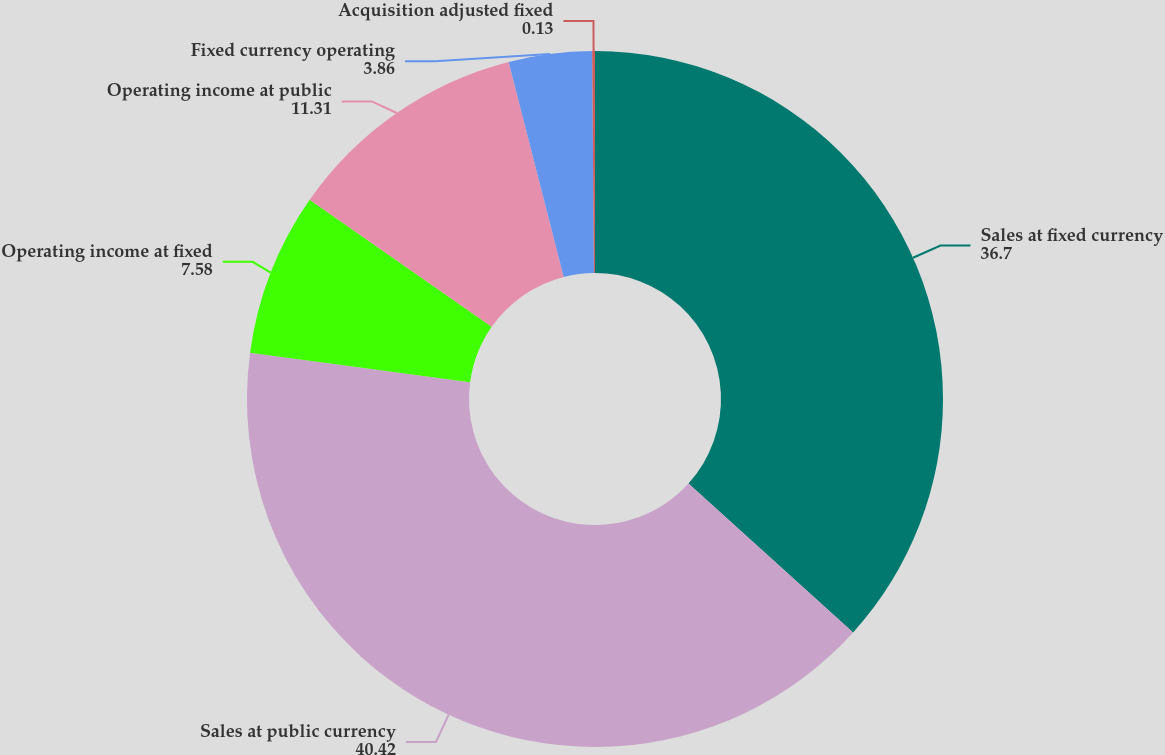Convert chart. <chart><loc_0><loc_0><loc_500><loc_500><pie_chart><fcel>Sales at fixed currency<fcel>Sales at public currency<fcel>Operating income at fixed<fcel>Operating income at public<fcel>Fixed currency operating<fcel>Acquisition adjusted fixed<nl><fcel>36.7%<fcel>40.42%<fcel>7.58%<fcel>11.31%<fcel>3.86%<fcel>0.13%<nl></chart> 